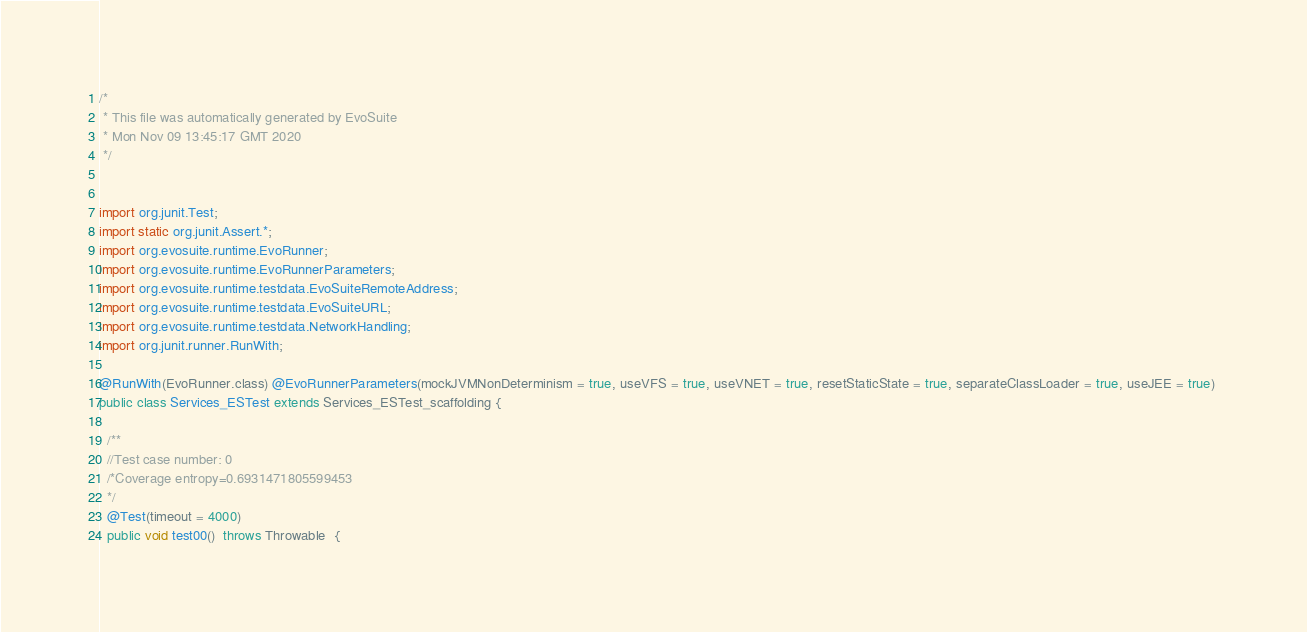<code> <loc_0><loc_0><loc_500><loc_500><_Java_>/*
 * This file was automatically generated by EvoSuite
 * Mon Nov 09 13:45:17 GMT 2020
 */


import org.junit.Test;
import static org.junit.Assert.*;
import org.evosuite.runtime.EvoRunner;
import org.evosuite.runtime.EvoRunnerParameters;
import org.evosuite.runtime.testdata.EvoSuiteRemoteAddress;
import org.evosuite.runtime.testdata.EvoSuiteURL;
import org.evosuite.runtime.testdata.NetworkHandling;
import org.junit.runner.RunWith;

@RunWith(EvoRunner.class) @EvoRunnerParameters(mockJVMNonDeterminism = true, useVFS = true, useVNET = true, resetStaticState = true, separateClassLoader = true, useJEE = true) 
public class Services_ESTest extends Services_ESTest_scaffolding {

  /**
  //Test case number: 0
  /*Coverage entropy=0.6931471805599453
  */
  @Test(timeout = 4000)
  public void test00()  throws Throwable  {</code> 